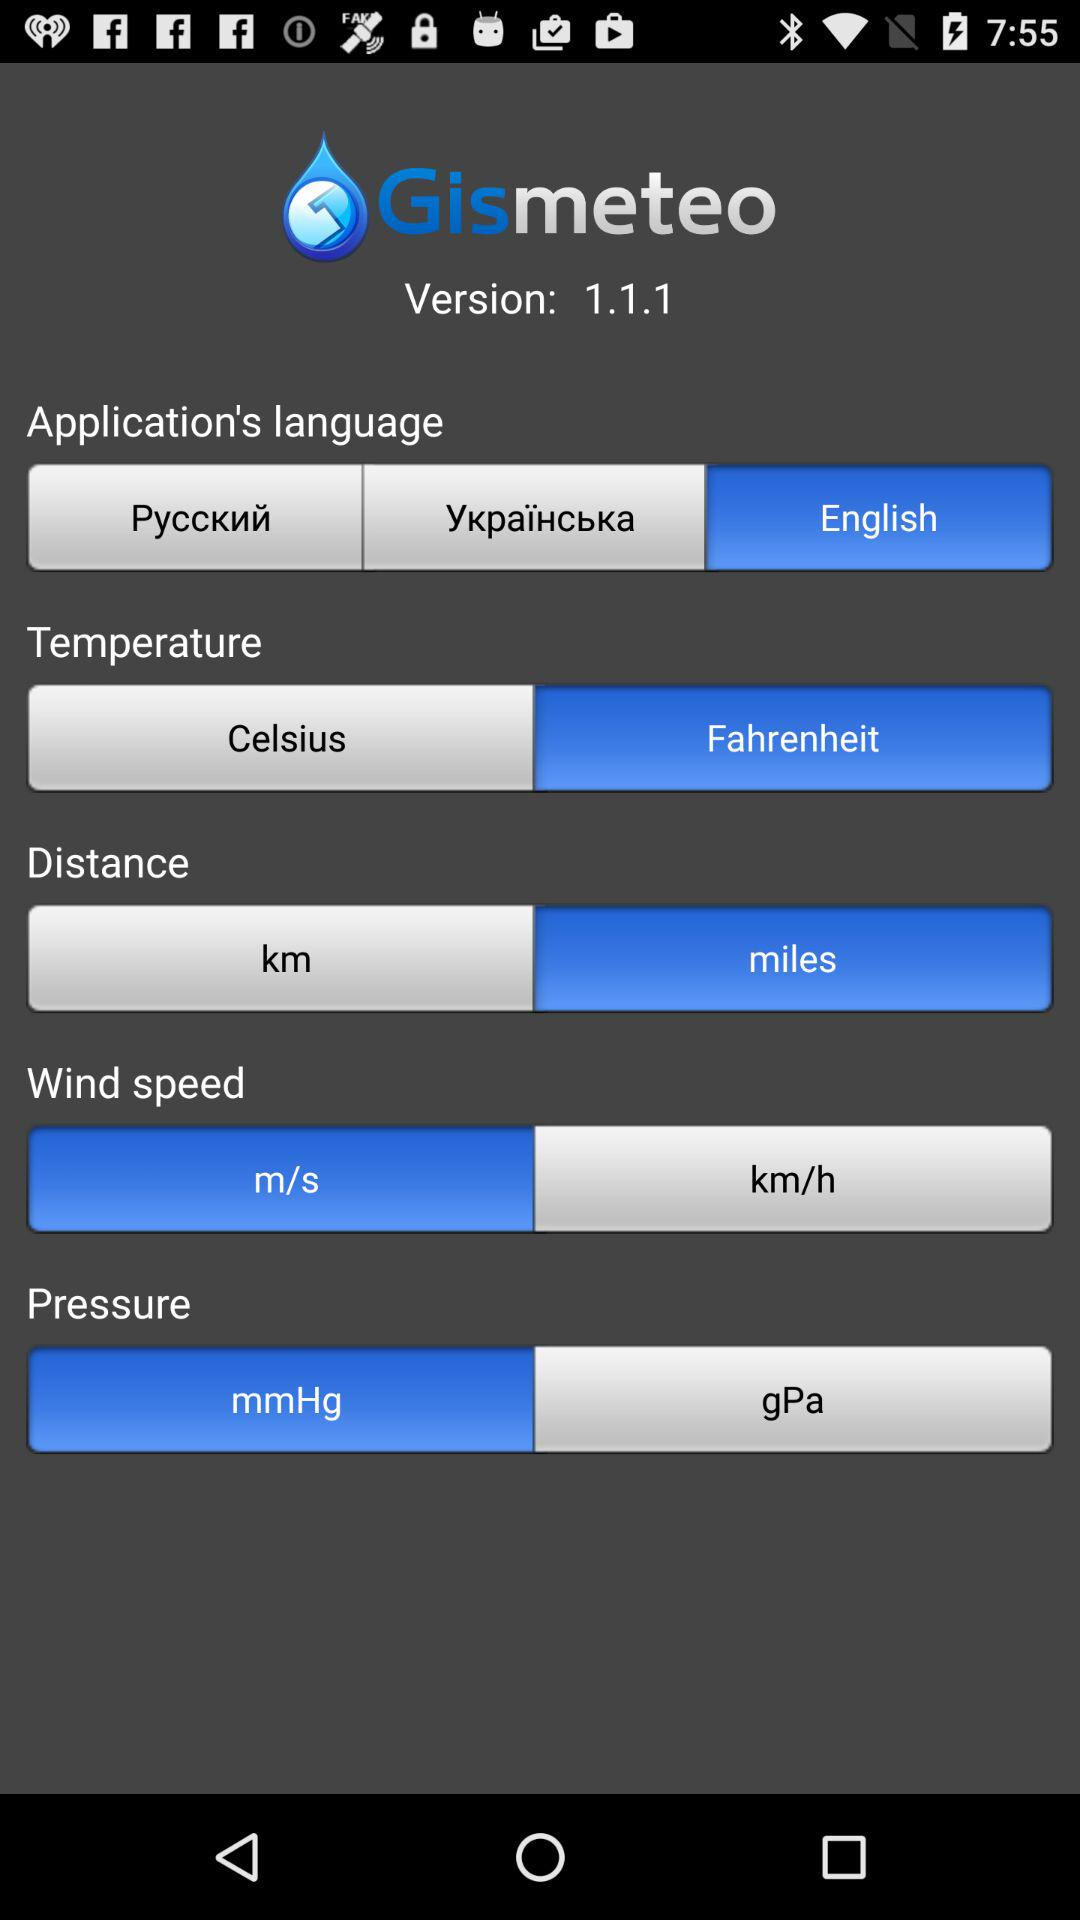How many language options are there?
Answer the question using a single word or phrase. 3 